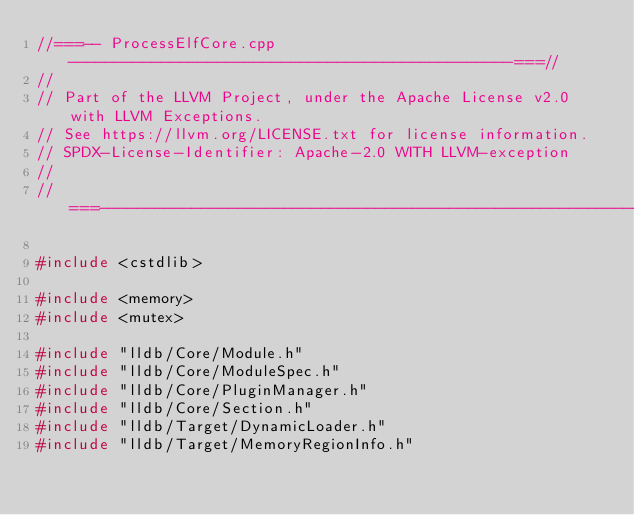Convert code to text. <code><loc_0><loc_0><loc_500><loc_500><_C++_>//===-- ProcessElfCore.cpp ------------------------------------------------===//
//
// Part of the LLVM Project, under the Apache License v2.0 with LLVM Exceptions.
// See https://llvm.org/LICENSE.txt for license information.
// SPDX-License-Identifier: Apache-2.0 WITH LLVM-exception
//
//===----------------------------------------------------------------------===//

#include <cstdlib>

#include <memory>
#include <mutex>

#include "lldb/Core/Module.h"
#include "lldb/Core/ModuleSpec.h"
#include "lldb/Core/PluginManager.h"
#include "lldb/Core/Section.h"
#include "lldb/Target/DynamicLoader.h"
#include "lldb/Target/MemoryRegionInfo.h"</code> 